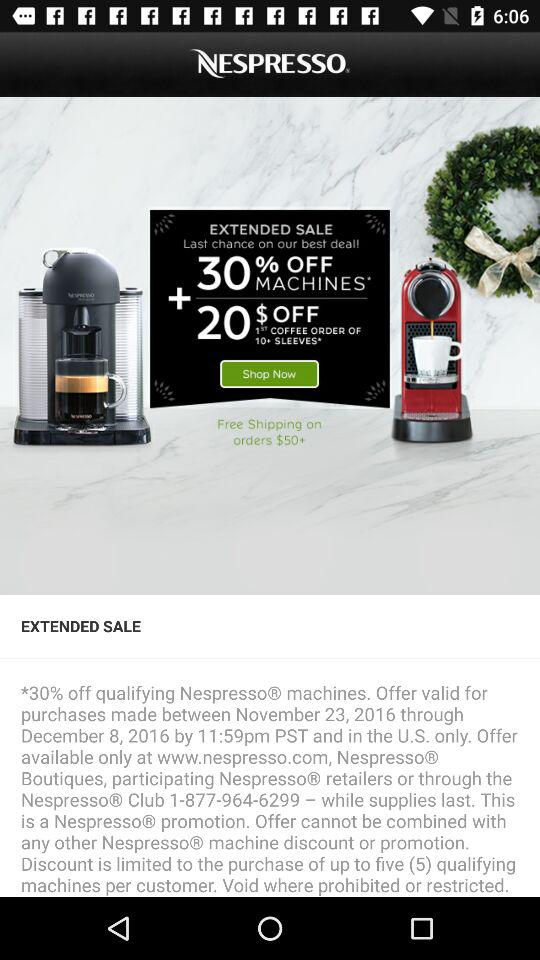Free shipping is applicable on orders above what price? Free shipping is applicable on orders above the price of 50 dollars. 